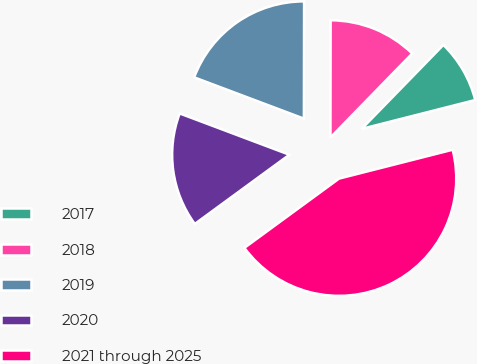Convert chart to OTSL. <chart><loc_0><loc_0><loc_500><loc_500><pie_chart><fcel>2017<fcel>2018<fcel>2019<fcel>2020<fcel>2021 through 2025<nl><fcel>8.75%<fcel>12.26%<fcel>19.3%<fcel>15.78%<fcel>43.91%<nl></chart> 